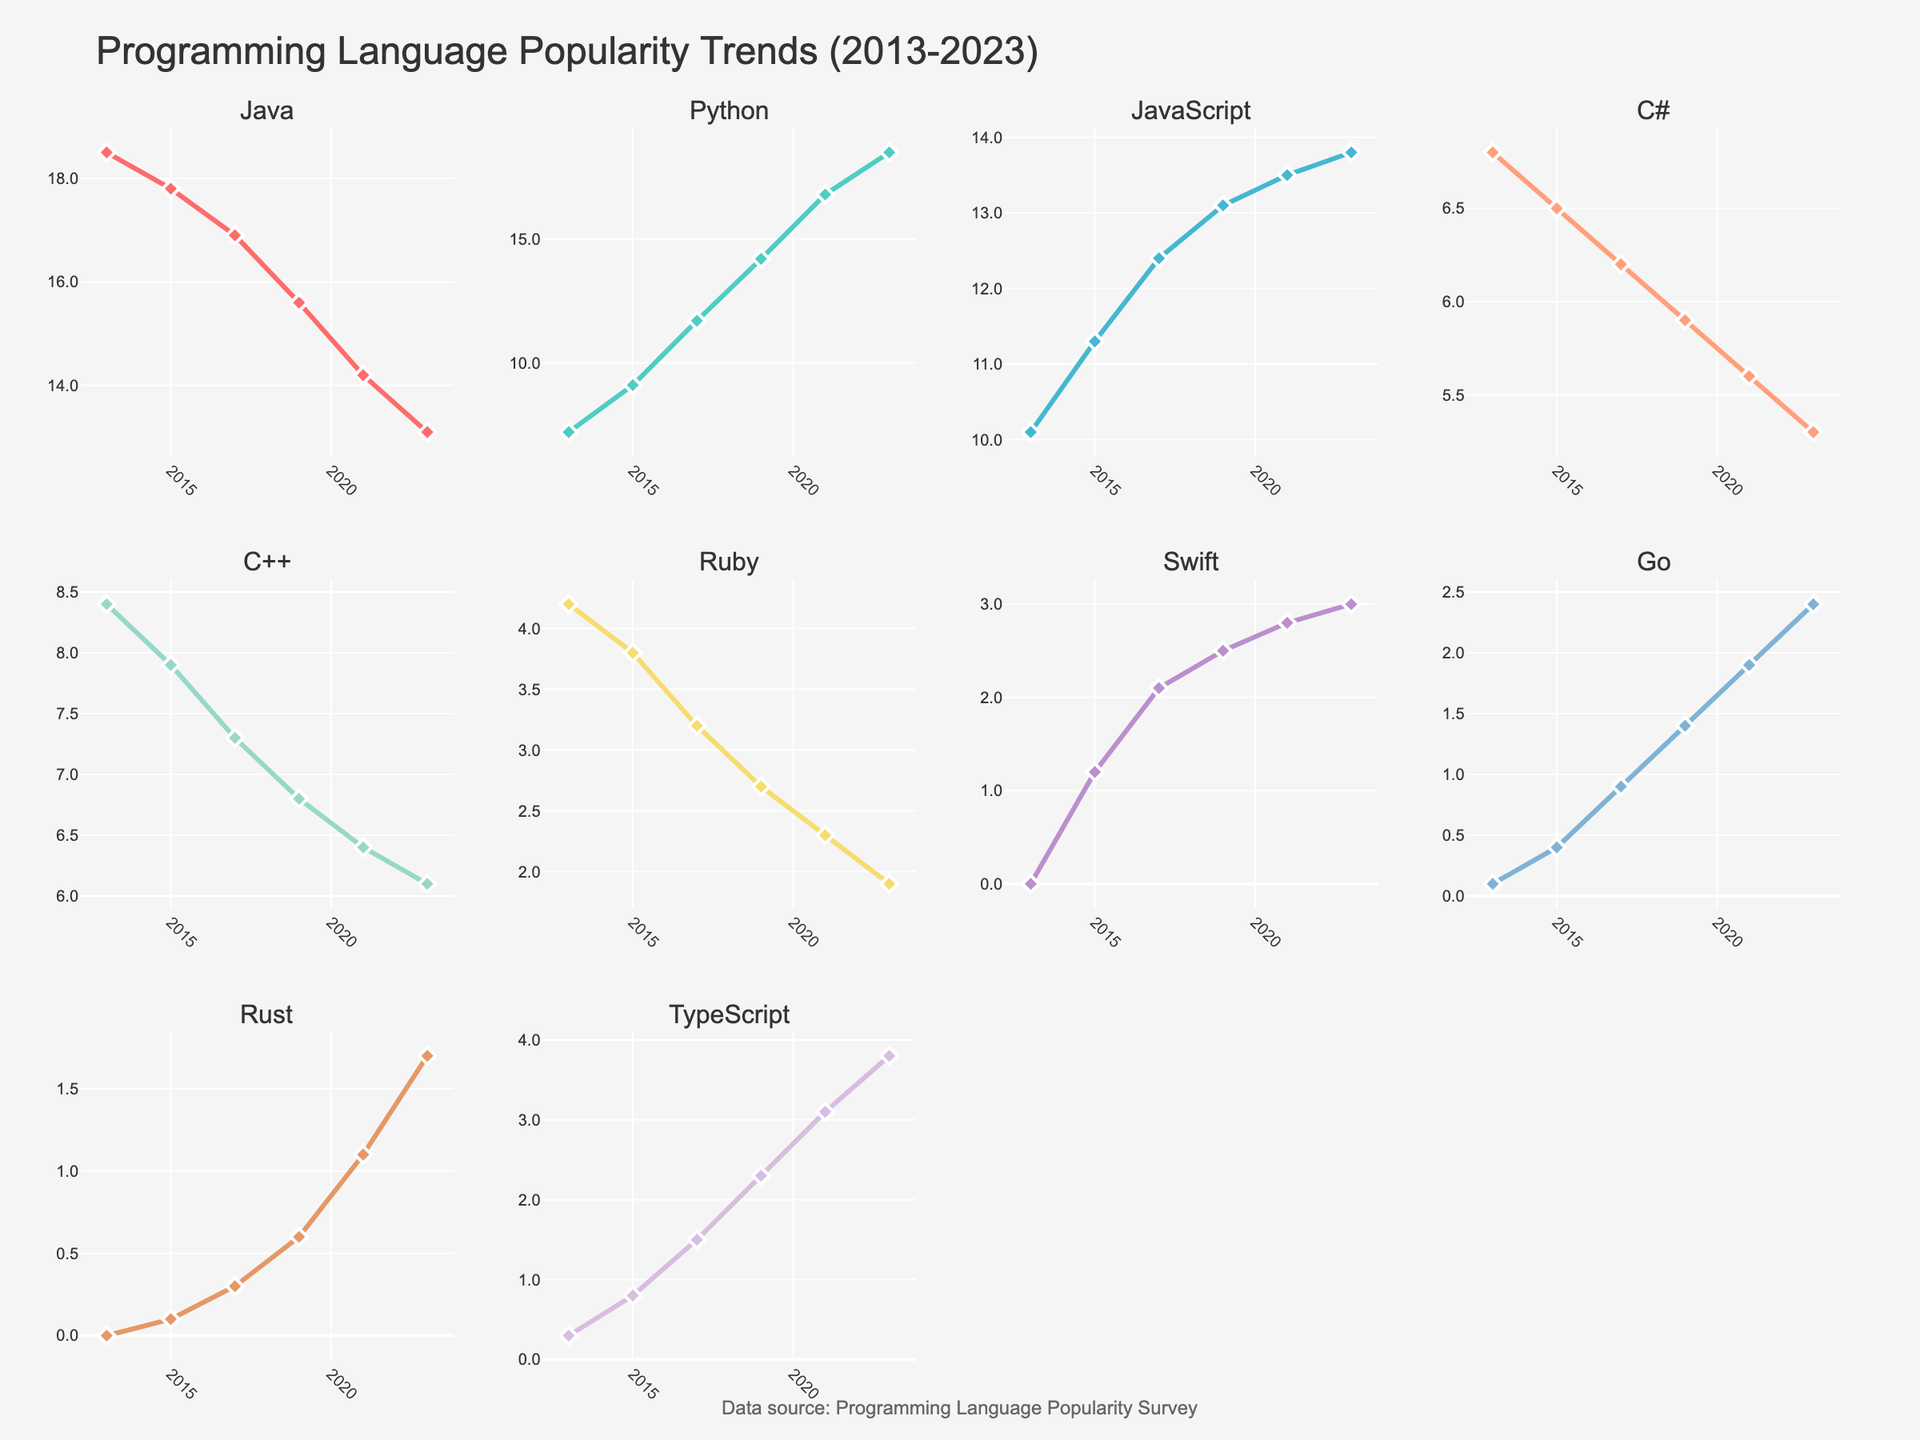What's the title of the figure? The title of the figure is displayed at the top and reads "Network Latency Distribution Across Video Streaming Protocols".
Answer: Network Latency Distribution Across Video Streaming Protocols Which protocol has the highest minimum latency? The minimum latency values are shown in the first subplot labeled "Min Latency". HLS has the highest value at 1000 ms.
Answer: HLS What is the range (difference between max and min latency) for WebRTC? WebRTC's max latency is 100 ms, and its min latency is 10 ms. The range is found by subtracting the min latency from the max latency: 100 - 10.
Answer: 90 ms Which protocols have a 95th percentile latency greater than 1000 ms? The 95th percentile latency values are shown in the fourth subplot. HLS, DASH, and SRT have values greater than 1000 ms.
Answer: HLS, DASH, SRT How does the average latency of SRT compare with WebRTC? SRT has an average latency of 55 ms and WebRTC has 35 ms. To compare, note that SRT's average latency is higher.
Answer: SRT has higher average latency than WebRTC What's the sum of the average latencies for NDI and RTMP? The average latency for NDI is 25 ms, and for RTMP, it is 45 ms. Adding these values gives 25 + 45.
Answer: 70 ms What is the lowest max latency across all protocols and which protocol does it belong to? The max latency values are visible in the third subplot. NDI has the lowest value at 80 ms.
Answer: NDI Which protocol shows the smallest range between its min and max latency? The ranges can be computed by subtracting the min from the max latency for each protocol. NDI has the smallest range (80 ms - 5 ms = 75 ms).
Answer: NDI Arrange the protocols in descending order of their 95th percentile latency. The 95th percentile latency values from highest to lowest are HLS (4200 ms), DASH (3800 ms), SRT (110 ms), RTMP (95 ms), WebRTC (80 ms), NDI (65 ms).
Answer: HLS, DASH, SRT, RTMP, WebRTC, NDI If you were to consider only the subplots showing "Min Latency" and "Max Latency," which protocol consistently shows the lowest latency and which one shows the highest variability? In the "Min Latency" subplot, NDI has the lowest latency at 5 ms. In the "Max Latency" subplot, HLS shows the highest value at 5000 ms. The highest variability can be inferred from the "Max Latency" since the difference between min and max is the largest for HLS.
Answer: NDI for lowest latency, HLS for highest variability 